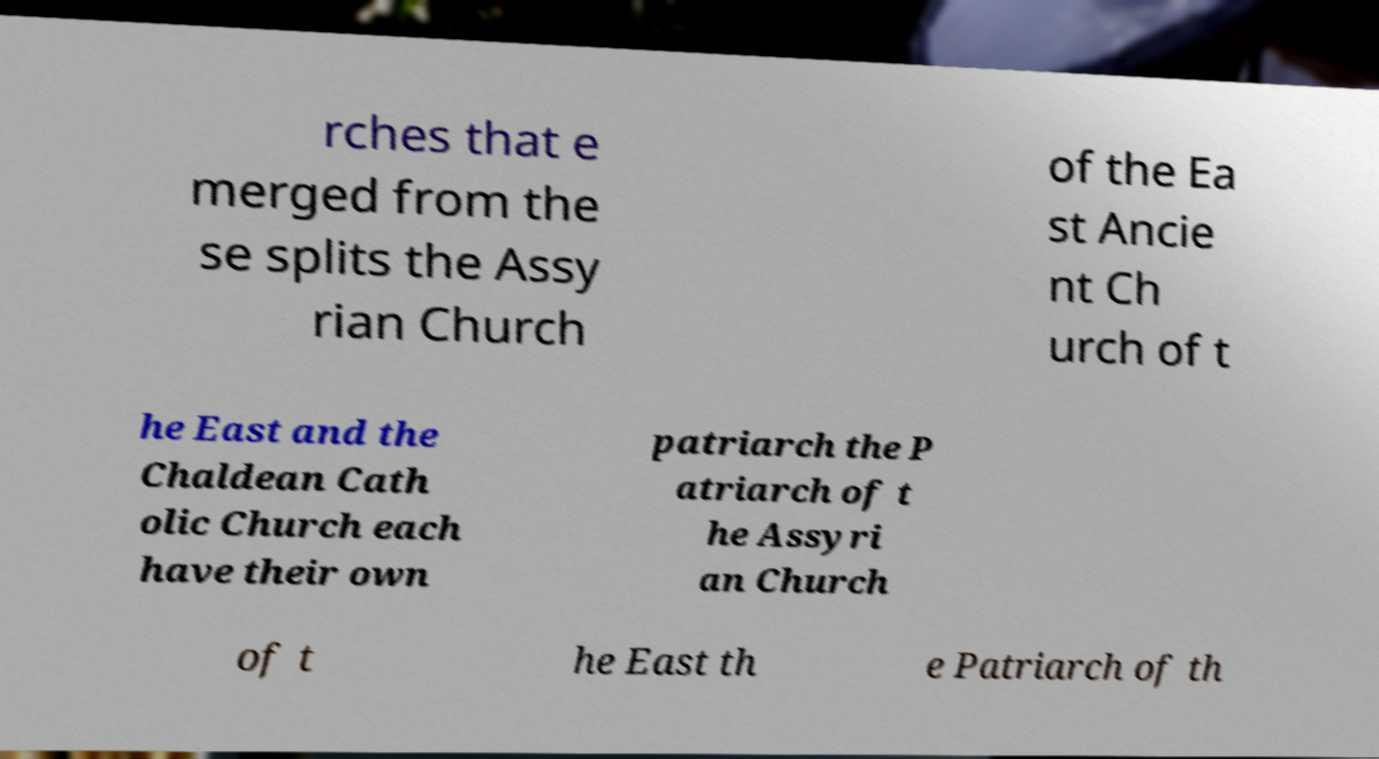Please identify and transcribe the text found in this image. rches that e merged from the se splits the Assy rian Church of the Ea st Ancie nt Ch urch of t he East and the Chaldean Cath olic Church each have their own patriarch the P atriarch of t he Assyri an Church of t he East th e Patriarch of th 